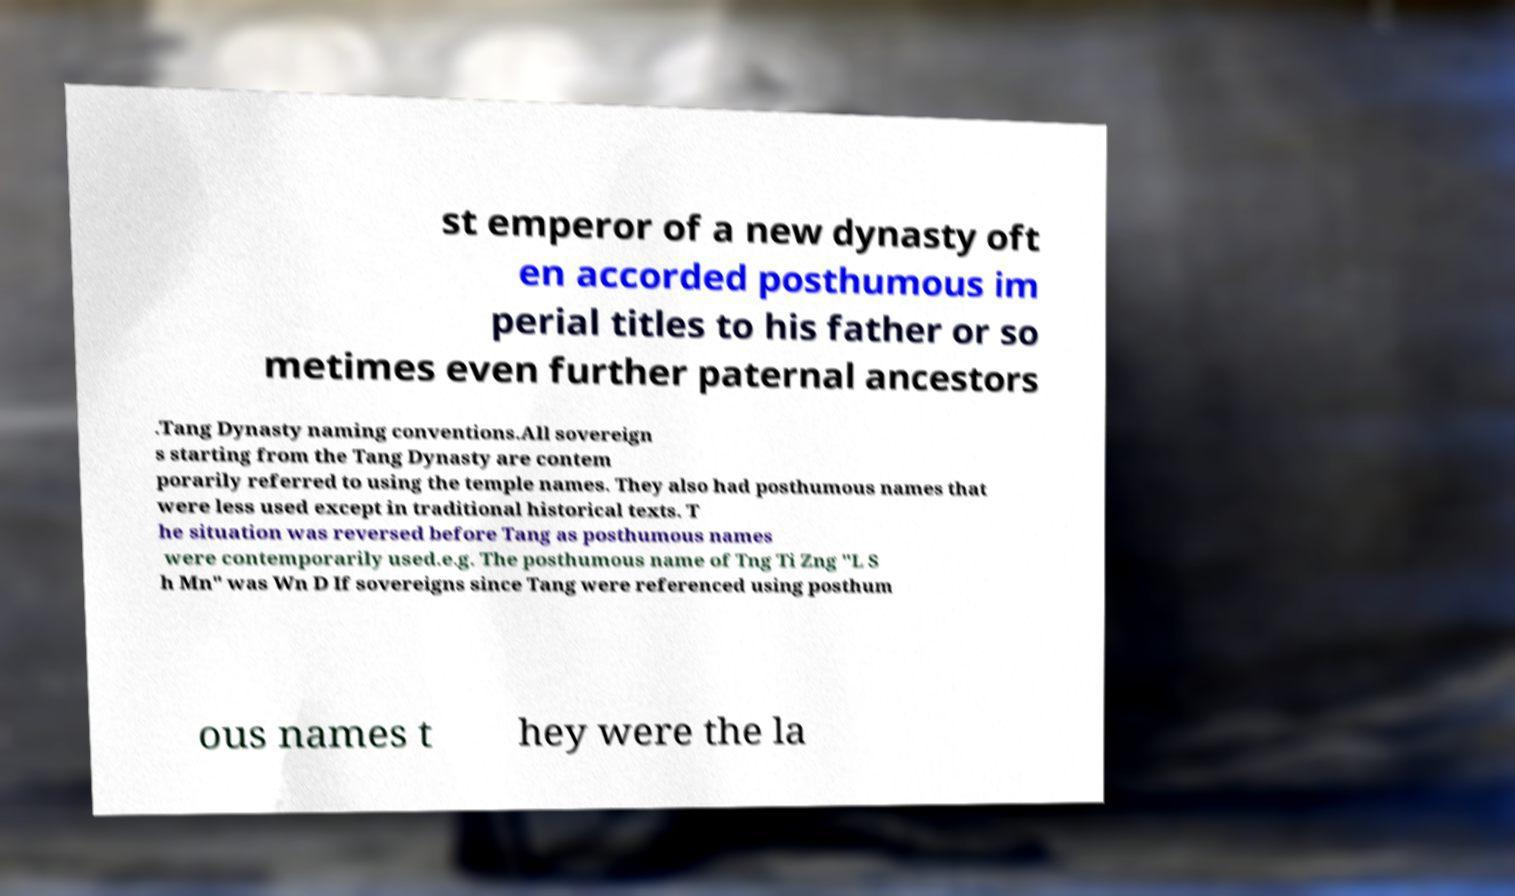For documentation purposes, I need the text within this image transcribed. Could you provide that? st emperor of a new dynasty oft en accorded posthumous im perial titles to his father or so metimes even further paternal ancestors .Tang Dynasty naming conventions.All sovereign s starting from the Tang Dynasty are contem porarily referred to using the temple names. They also had posthumous names that were less used except in traditional historical texts. T he situation was reversed before Tang as posthumous names were contemporarily used.e.g. The posthumous name of Tng Ti Zng "L S h Mn" was Wn D If sovereigns since Tang were referenced using posthum ous names t hey were the la 